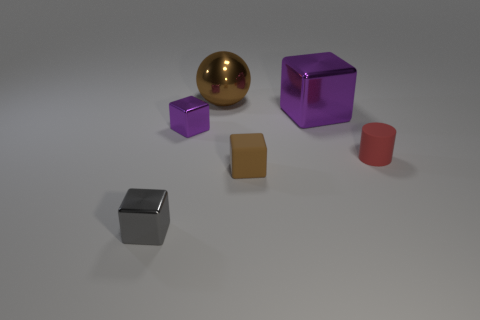What is the material of the thing that is the same color as the small matte cube?
Provide a short and direct response. Metal. There is a small red rubber object; are there any red matte cylinders to the left of it?
Offer a very short reply. No. Is the number of large brown spheres greater than the number of tiny metal cubes?
Give a very brief answer. No. What is the color of the large thing that is in front of the thing that is behind the metallic object that is to the right of the ball?
Your response must be concise. Purple. The big block that is made of the same material as the large brown ball is what color?
Offer a terse response. Purple. What number of things are either metal objects right of the tiny gray cube or small metal objects that are behind the small gray metallic cube?
Offer a very short reply. 3. There is a shiny block to the right of the small purple metal thing; is it the same size as the shiny block that is in front of the cylinder?
Ensure brevity in your answer.  No. What color is the other big thing that is the same shape as the brown matte thing?
Make the answer very short. Purple. Is there anything else that is the same shape as the small brown thing?
Make the answer very short. Yes. Are there more matte things in front of the red object than rubber things in front of the brown matte object?
Offer a terse response. Yes. 